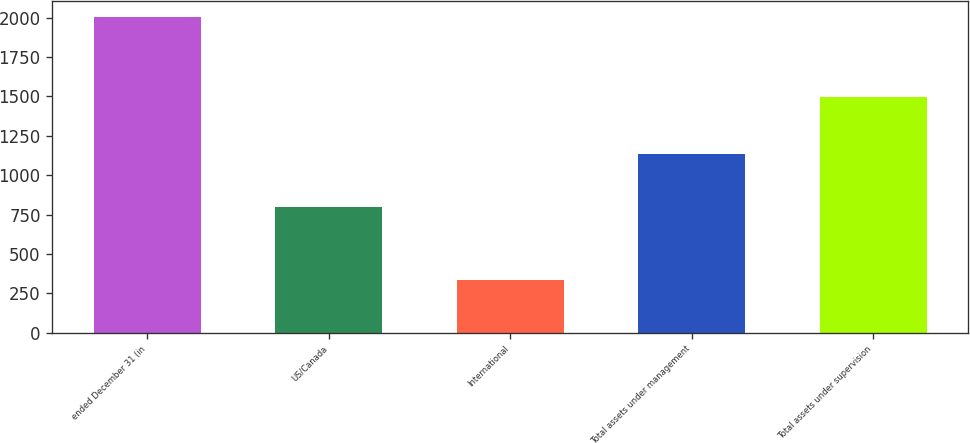Convert chart. <chart><loc_0><loc_0><loc_500><loc_500><bar_chart><fcel>ended December 31 (in<fcel>US/Canada<fcel>International<fcel>Total assets under management<fcel>Total assets under supervision<nl><fcel>2008<fcel>798<fcel>335<fcel>1133<fcel>1496<nl></chart> 